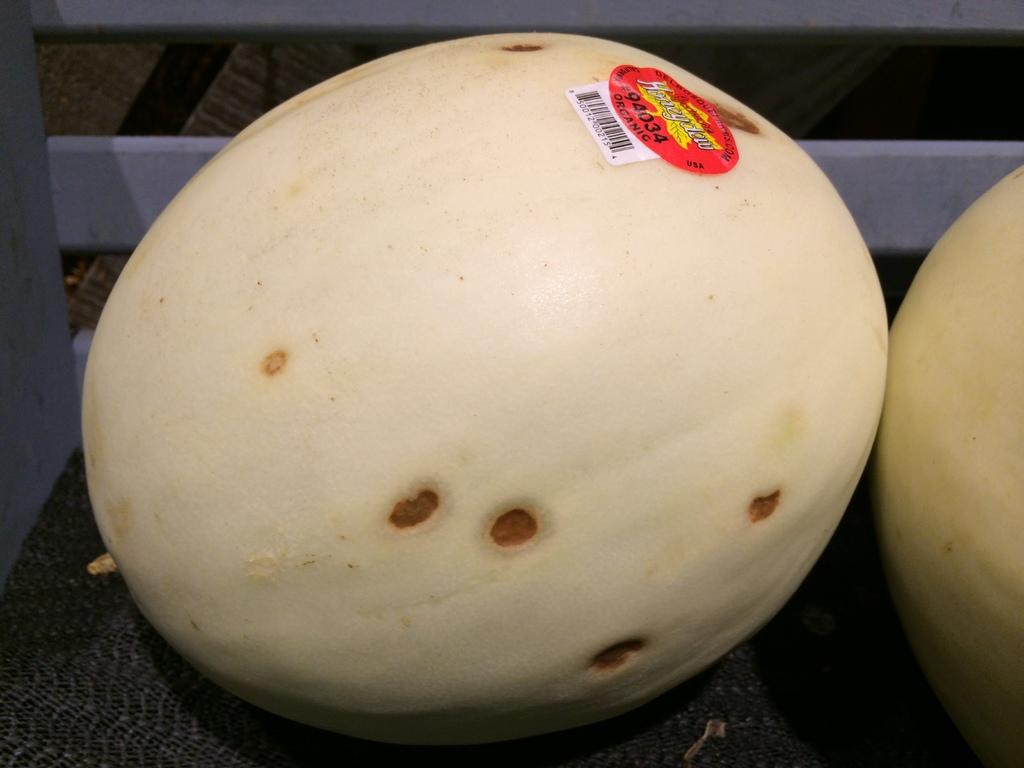What color are the pumpkins in the image? The pumpkins in the image are cream-colored. What is the pumpkins resting on in the image? The pumpkins are on a black-colored mat. Is there any additional marking on one of the pumpkins? Yes, one of the pumpkins has a red-colored sticker. What can be seen to the left in the image? There is a wall visible to the left in the image. What is the name of the baby born in the image? There is no baby or birth depicted in the image; it features cream-colored pumpkins on a black-colored mat. 